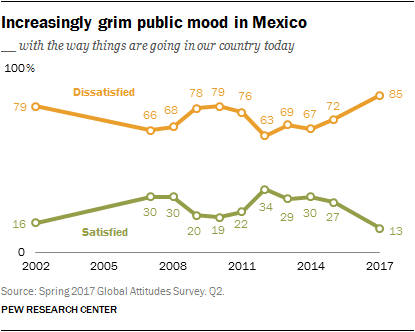Highlight a few significant elements in this photo. The satisfied line reached the peak in 2012. The satisfied rate has been above 25 at least 6 times. 